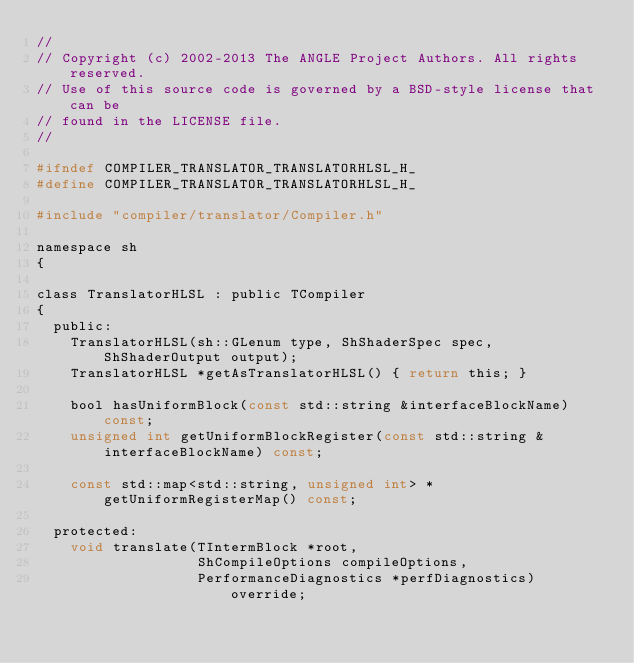<code> <loc_0><loc_0><loc_500><loc_500><_C_>//
// Copyright (c) 2002-2013 The ANGLE Project Authors. All rights reserved.
// Use of this source code is governed by a BSD-style license that can be
// found in the LICENSE file.
//

#ifndef COMPILER_TRANSLATOR_TRANSLATORHLSL_H_
#define COMPILER_TRANSLATOR_TRANSLATORHLSL_H_

#include "compiler/translator/Compiler.h"

namespace sh
{

class TranslatorHLSL : public TCompiler
{
  public:
    TranslatorHLSL(sh::GLenum type, ShShaderSpec spec, ShShaderOutput output);
    TranslatorHLSL *getAsTranslatorHLSL() { return this; }

    bool hasUniformBlock(const std::string &interfaceBlockName) const;
    unsigned int getUniformBlockRegister(const std::string &interfaceBlockName) const;

    const std::map<std::string, unsigned int> *getUniformRegisterMap() const;

  protected:
    void translate(TIntermBlock *root,
                   ShCompileOptions compileOptions,
                   PerformanceDiagnostics *perfDiagnostics) override;</code> 